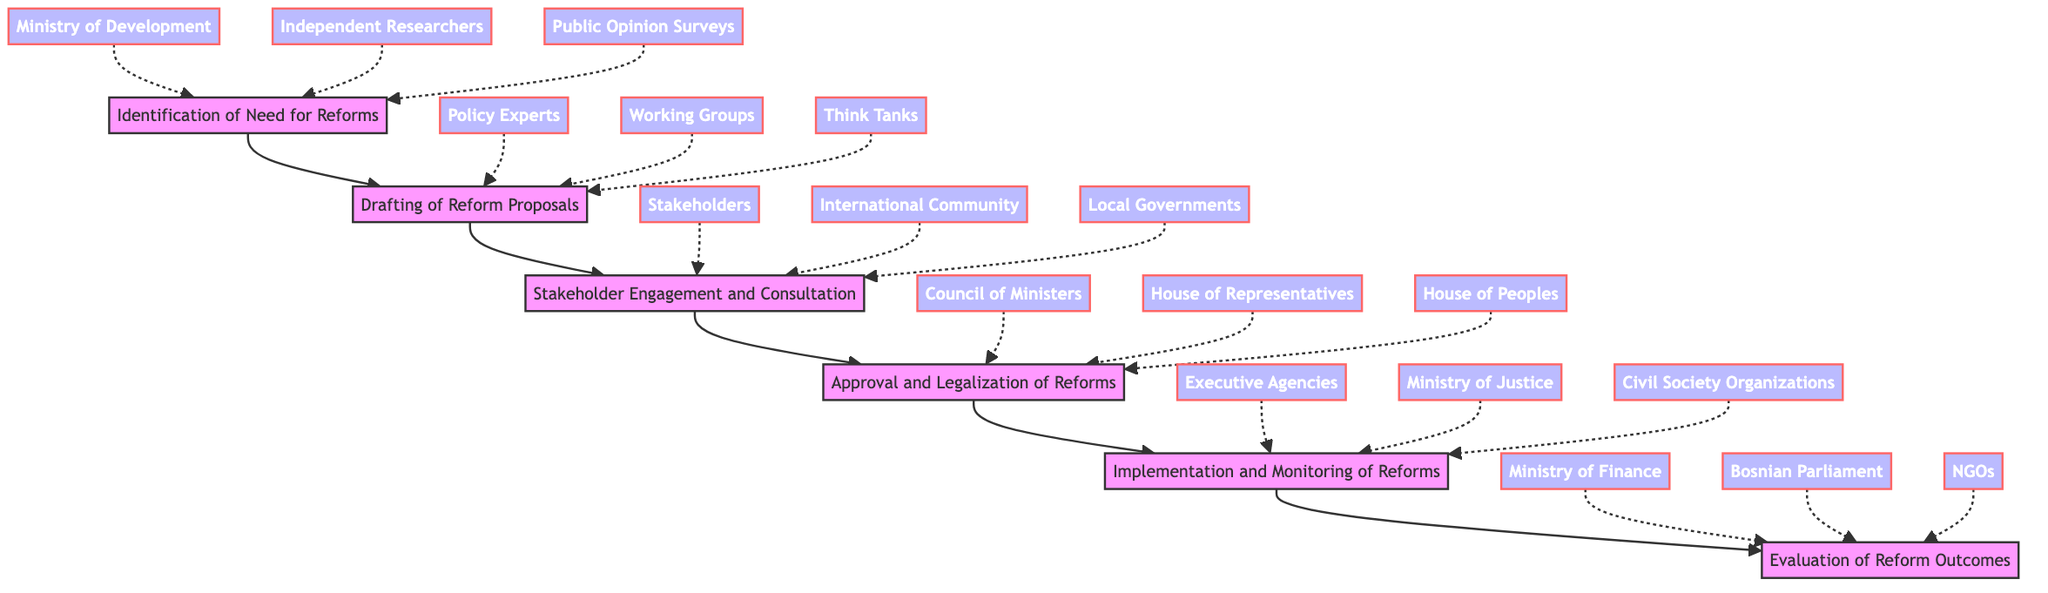What is the first step in the flow? The flow starts with the "Identification of Need for Reforms" step, which is at the bottom of the diagram.
Answer: Identification of Need for Reforms How many steps are in the flow chart? There are six steps in the flow chart, listed vertically from the bottom up.
Answer: Six Which entities are involved in the "Implementation and Monitoring of Reforms" step? The entities involved in this step are "Executive Agencies," "Ministry of Justice," and "Civil Society Organizations," which are directly connected to this node.
Answer: Executive Agencies, Ministry of Justice, Civil Society Organizations What step comes directly before "Evaluation of Reform Outcomes"? The step that comes directly before "Evaluation of Reform Outcomes" is "Implementation and Monitoring of Reforms."
Answer: Implementation and Monitoring of Reforms Which step involves the Council of Ministers? The "Approval and Legalization of Reforms" step involves the "Council of Ministers," as it is one of the entities listed under this node.
Answer: Approval and Legalization of Reforms What is the last step in the reform process, according to the diagram? The last step in the reform process, as indicated at the top of the flow chart, is "Evaluation of Reform Outcomes."
Answer: Evaluation of Reform Outcomes Which groups are involved in the drafting of reform proposals? The groups involved in this step include "Policy Experts," "Working Groups," and "Think Tanks," which can be seen associated with the "Drafting of Reform Proposals."
Answer: Policy Experts, Working Groups, Think Tanks What is the purpose of stakeholder engagement? The purpose of stakeholder engagement is to gather feedback on the proposed reforms, as indicated in the description of the "Stakeholder Engagement and Consultation" step.
Answer: Gather feedback Which two entities are responsible for the approval of reforms? The two entities responsible for the approval of reforms are the "House of Representatives" and "House of Peoples," along with the "Council of Ministers."
Answer: House of Representatives, House of Peoples 